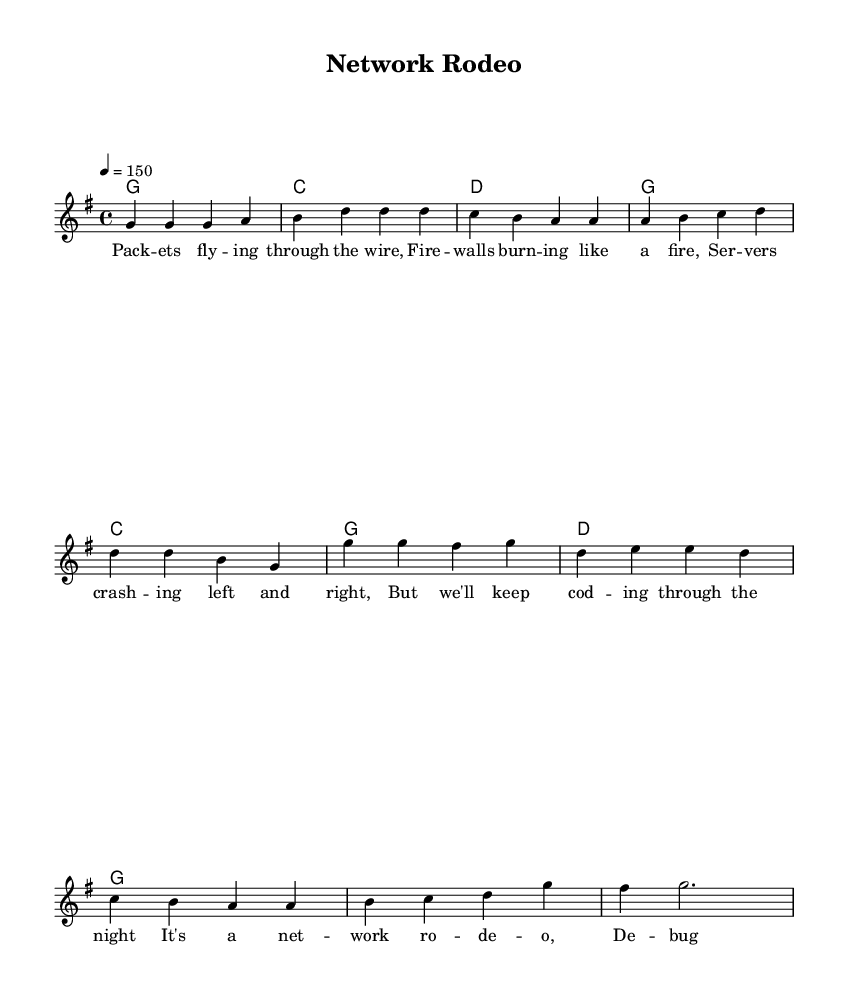What is the key signature of this music? The key signature is indicated at the beginning of the score. Since there is one sharp (F#) present, it means the key is G major.
Answer: G major What is the time signature of this music? The time signature is shown at the beginning of the score following the key signature. It is indicated as 4/4, meaning there are four beats per measure.
Answer: 4/4 What is the tempo marking for this piece? The tempo marking is located in the global section and is written as "4 = 150," which means there are 150 beats per minute.
Answer: 150 How many measures are in the verse section? The verse section consists of a total of four measures, as counted from the melody line provided.
Answer: 4 What is the first word of the chorus? The lyrics are listed under the melody, and the chorus begins with the phrase "It's a," making the first word "It's."
Answer: It's What type of musical genre does this piece belong to? The title "Network Rodeo" along with the upbeat style and themes mentioned in the lyrics indicates that the piece falls under the Country Rock genre.
Answer: Country Rock How many chords are used in the verse? The chord names section outlines the chords played in the verse. There are four chords: G, C, D, and G listed in each of the four measures.
Answer: 4 